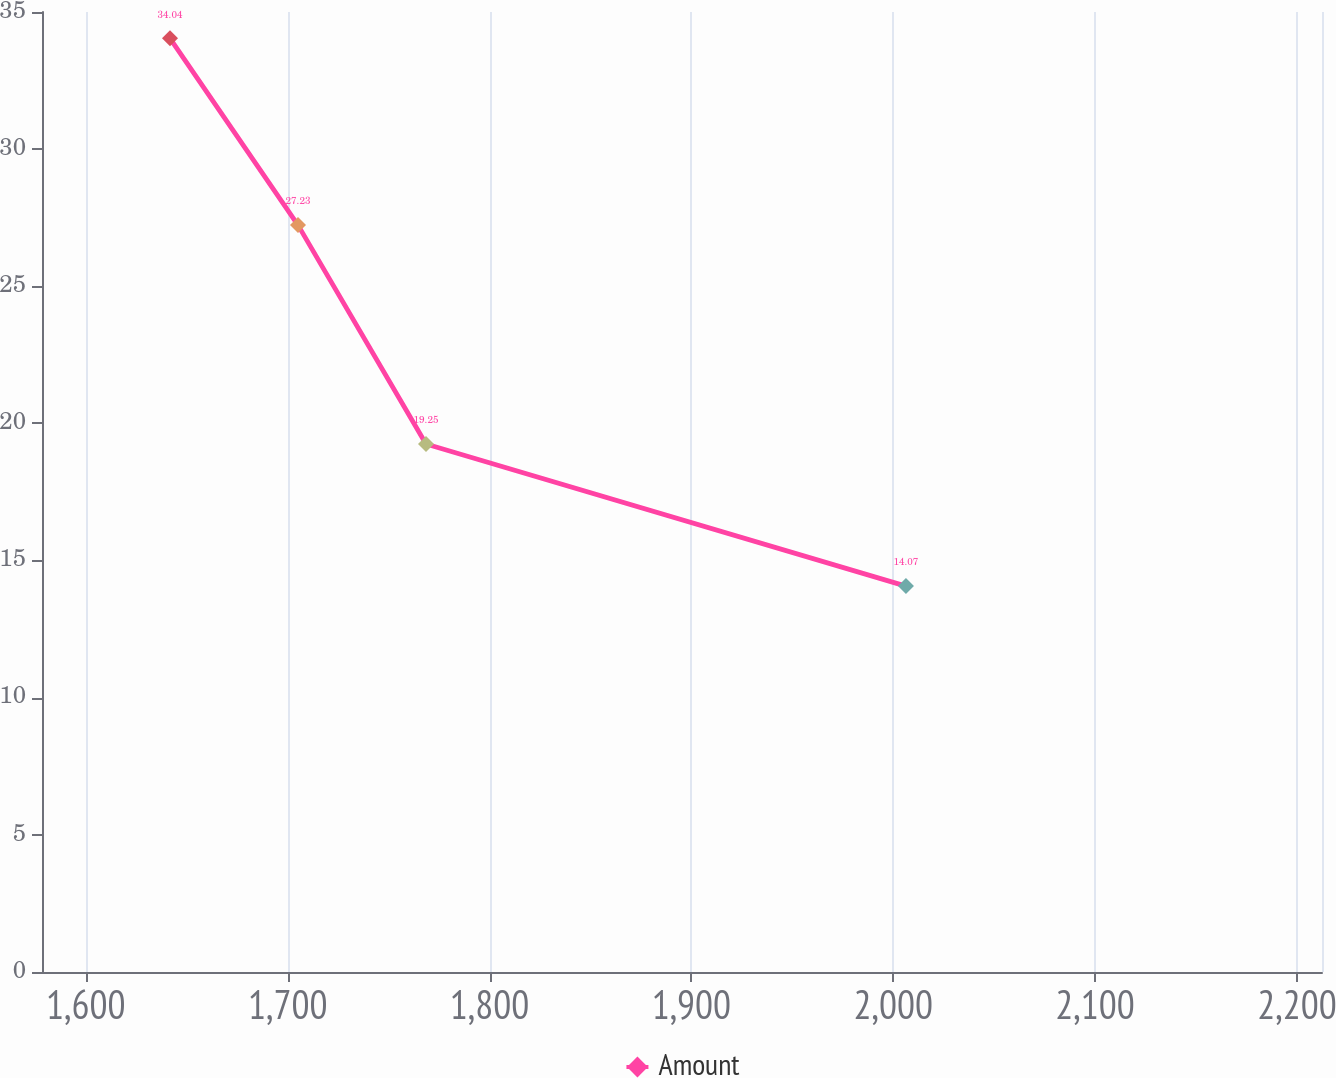<chart> <loc_0><loc_0><loc_500><loc_500><line_chart><ecel><fcel>Amount<nl><fcel>1641.7<fcel>34.04<nl><fcel>1705.11<fcel>27.23<nl><fcel>1768.52<fcel>19.25<nl><fcel>2006.28<fcel>14.07<nl><fcel>2275.83<fcel>11.85<nl></chart> 